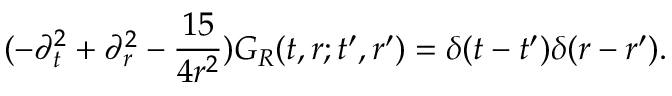Convert formula to latex. <formula><loc_0><loc_0><loc_500><loc_500>( - \partial _ { t } ^ { 2 } + \partial _ { r } ^ { 2 } - \frac { 1 5 } { 4 r ^ { 2 } } ) G _ { R } ( t , r ; t ^ { \prime } , r ^ { \prime } ) = \delta ( t - t ^ { \prime } ) \delta ( r - r ^ { \prime } ) .</formula> 